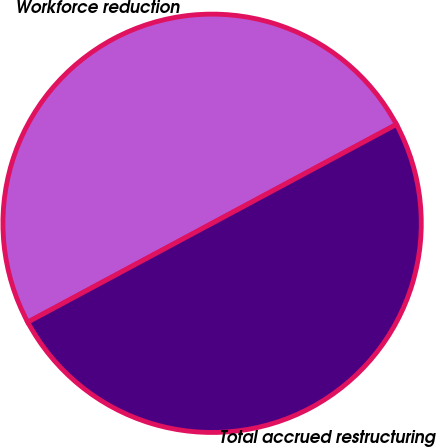<chart> <loc_0><loc_0><loc_500><loc_500><pie_chart><fcel>Workforce reduction<fcel>Total accrued restructuring<nl><fcel>50.0%<fcel>50.0%<nl></chart> 